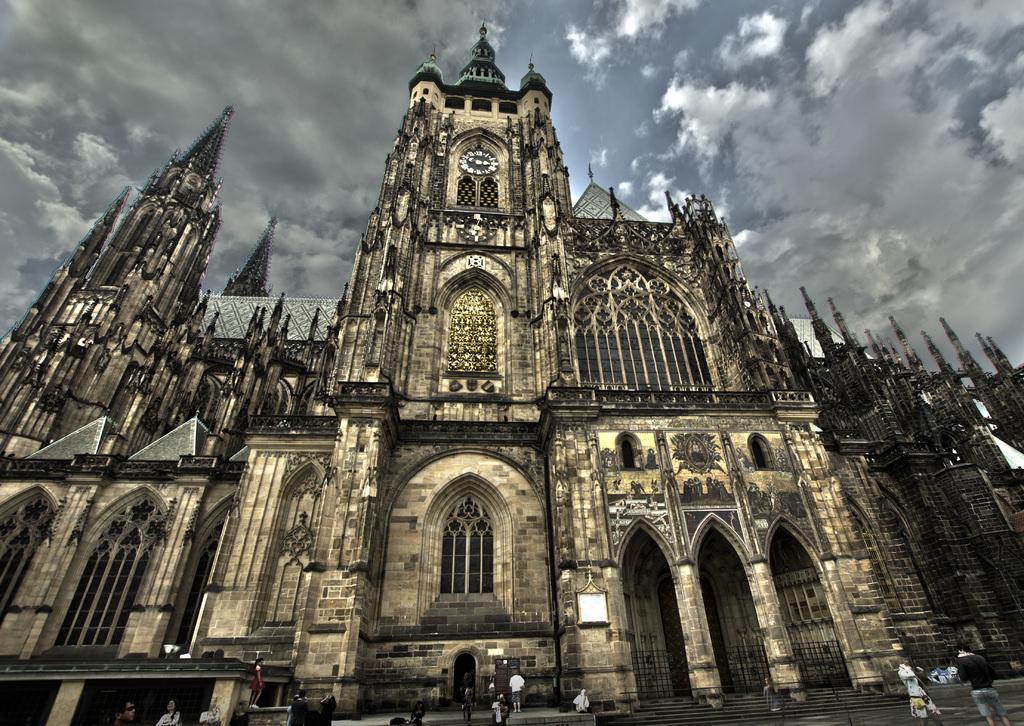Can you describe this image briefly? This picture is clicked outside. In the foreground we can see the group of people and in the center there is a building and the spire and we can see the clock is hanging on the wall. In the background there is a sky which is full of clouds. 